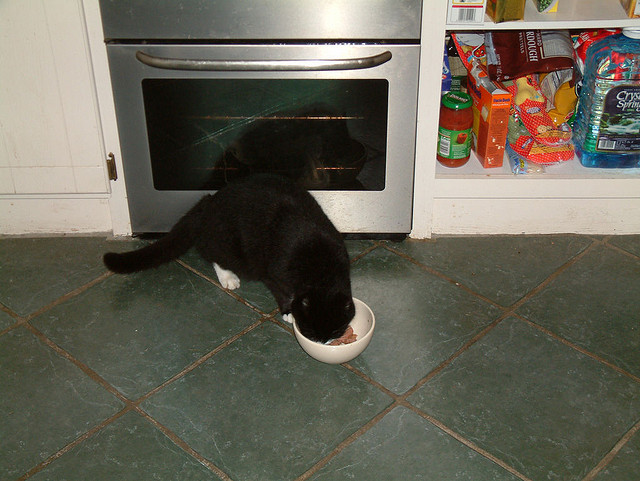Identify and read out the text in this image. ROOUGH 